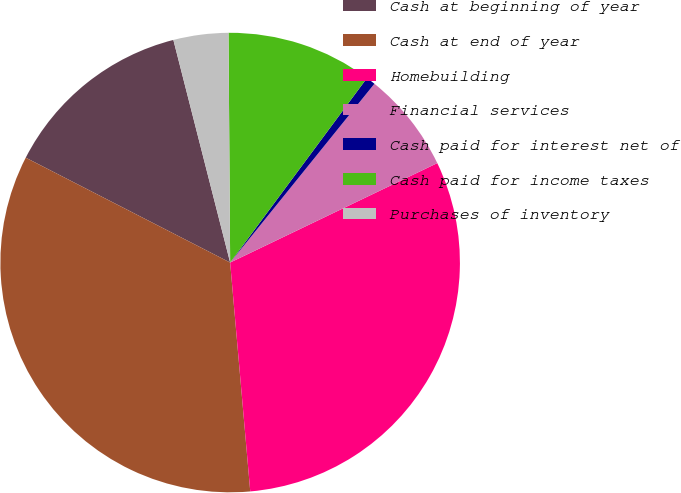Convert chart to OTSL. <chart><loc_0><loc_0><loc_500><loc_500><pie_chart><fcel>Cash at beginning of year<fcel>Cash at end of year<fcel>Homebuilding<fcel>Financial services<fcel>Cash paid for interest net of<fcel>Cash paid for income taxes<fcel>Purchases of inventory<nl><fcel>13.48%<fcel>33.94%<fcel>30.73%<fcel>7.07%<fcel>0.65%<fcel>10.27%<fcel>3.86%<nl></chart> 